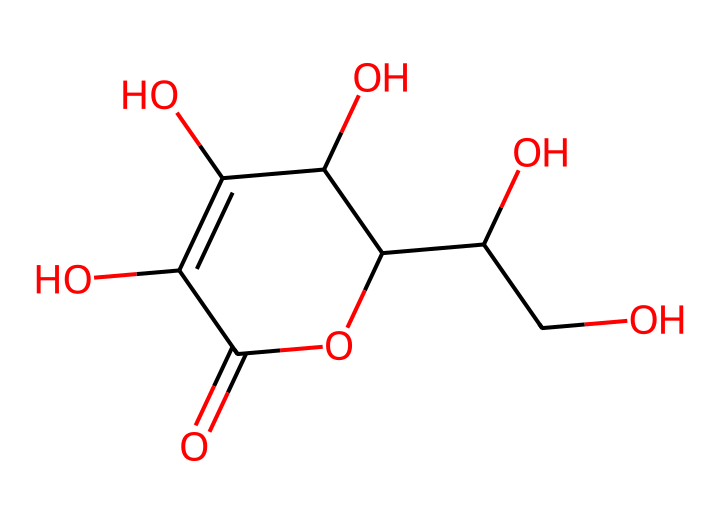What is the molecular formula of vitamin C? To determine the molecular formula from the SMILES representation, we identify the elements and count their occurrences. In the given SMILES, we have 6 carbon (C), 8 hydrogen (H), and 6 oxygen (O) atoms. Therefore, the molecular formula can be summarized as C6H8O6.
Answer: C6H8O6 How many hydroxyl (–OH) groups are present in this structure? By examining the SMILES, we can locate the hydroxyl groups, which are represented by the 'O' connected to 'C' in various parts of the molecule. In total, we count four hydroxyl groups present in the structural representation.
Answer: 4 What type of chemical reaction does vitamin C primarily participate in to aid collagen synthesis? Vitamin C primarily participates in redox reactions, specifically acting as a reducing agent to convert proline and lysine into hydroxyproline and hydroxylysine, crucial for collagen stabilization.
Answer: redox Does vitamin C have any double bonds in its structure? To identify double bonds, we observe the presence of double connections in the SMILES representation, indicated without single bond marks. The structure contains two double bonds, which are denoted by '=' between carbon and oxygen atoms.
Answer: Yes What role does vitamin C play in skin health? Vitamin C is essential for collagen synthesis, helping improve the skin's elasticity and firmness, which contributes to overall skin health appearance and resilience.
Answer: collagen synthesis How many rings are formed in the structure of vitamin C? In the provided SMILES representation, the numeral '1' indicates the start and end of a ring; upon examination, we see that there is one complete ring structure formed, differentiating it from other linear or branched portions.
Answer: 1 